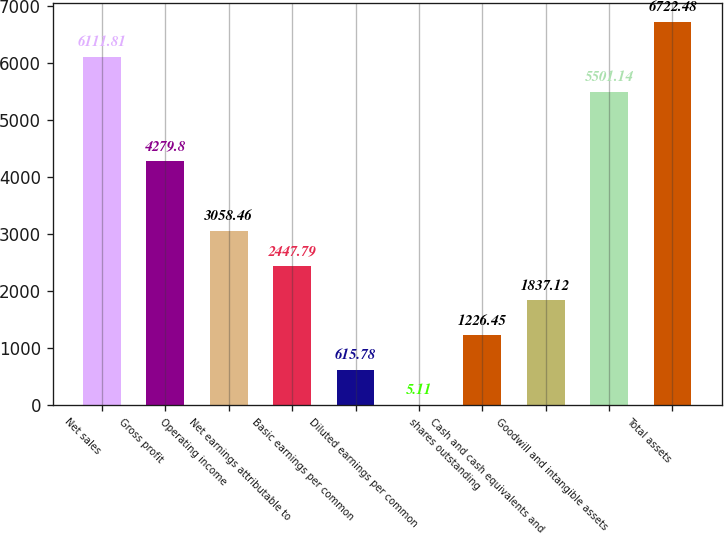Convert chart. <chart><loc_0><loc_0><loc_500><loc_500><bar_chart><fcel>Net sales<fcel>Gross profit<fcel>Operating income<fcel>Net earnings attributable to<fcel>Basic earnings per common<fcel>Diluted earnings per common<fcel>shares outstanding<fcel>Cash and cash equivalents and<fcel>Goodwill and intangible assets<fcel>Total assets<nl><fcel>6111.81<fcel>4279.8<fcel>3058.46<fcel>2447.79<fcel>615.78<fcel>5.11<fcel>1226.45<fcel>1837.12<fcel>5501.14<fcel>6722.48<nl></chart> 